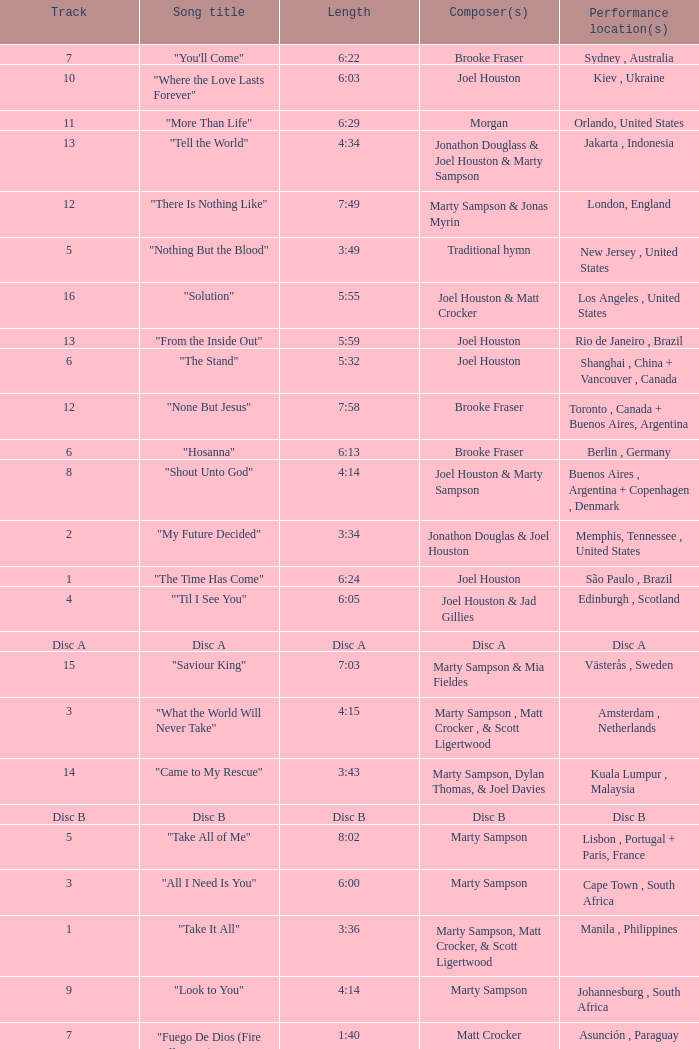Who is the composer of the song with a length of 6:24? Joel Houston. 